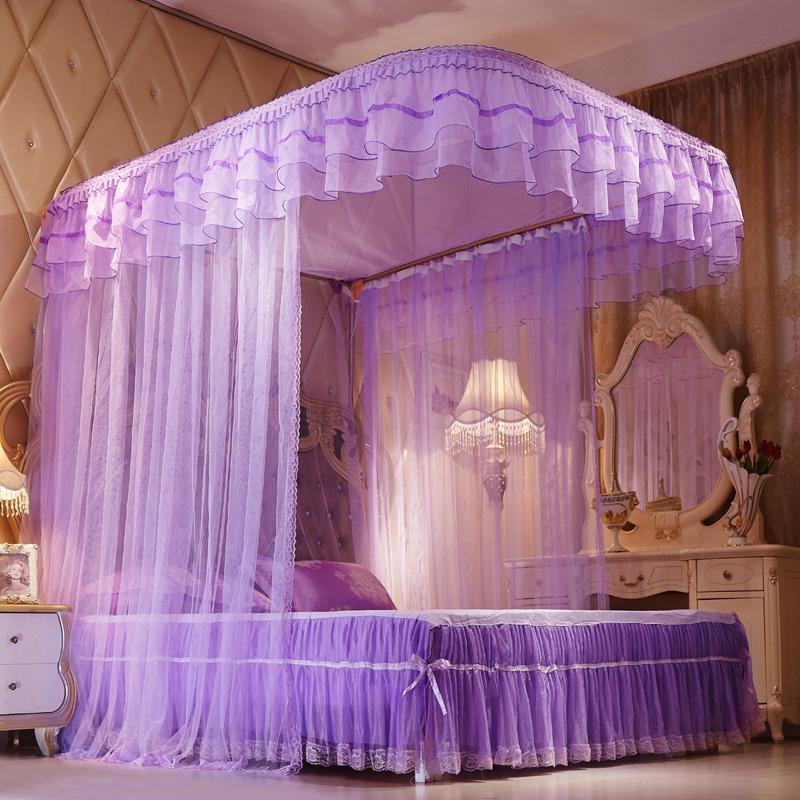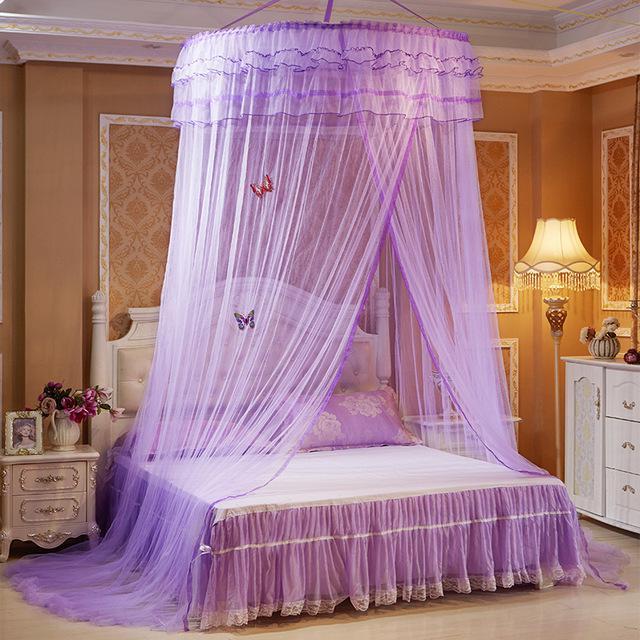The first image is the image on the left, the second image is the image on the right. Considering the images on both sides, is "The left and right image contains the same number of purple canopies." valid? Answer yes or no. Yes. The first image is the image on the left, the second image is the image on the right. Assess this claim about the two images: "Each image shows a bed with purple ruffled layers above it, and one of the images shows sheer purple draping at least two sides of the bed from a canopy the same shape as the bed.". Correct or not? Answer yes or no. Yes. 